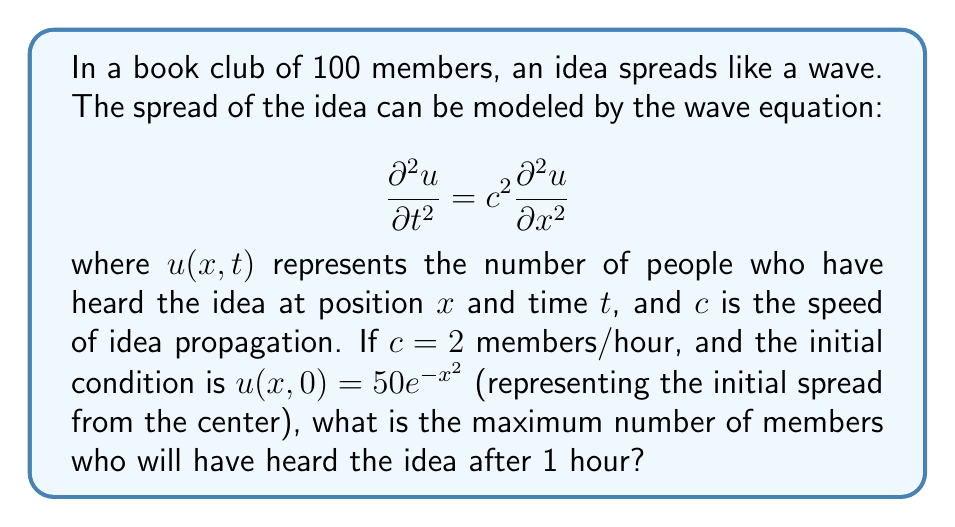Give your solution to this math problem. To solve this problem, we need to use the solution to the wave equation in one dimension:

$$u(x,t) = \frac{1}{2}[f(x+ct) + f(x-ct)]$$

where $f(x)$ is the initial condition.

Step 1: Identify the initial condition
$f(x) = 50e^{-x^2}$

Step 2: Substitute into the solution
$$u(x,1) = \frac{1}{2}[50e^{-(x+2)^2} + 50e^{-(x-2)^2}]$$

Step 3: To find the maximum, we need to find where $\frac{\partial u}{\partial x} = 0$
$$\frac{\partial u}{\partial x} = \frac{1}{2}[-100(x+2)e^{-(x+2)^2} - 100(x-2)e^{-(x-2)^2}] = 0$$

Step 4: This equation is satisfied when $x = 0$ due to symmetry

Step 5: Calculate the maximum value
$$u(0,1) = \frac{1}{2}[50e^{-4} + 50e^{-4}] = 50e^{-4}$$

Step 6: Round to the nearest whole number (as we're dealing with people)
$50e^{-4} \approx 0.9197 \approx 1$
Answer: 1 member 